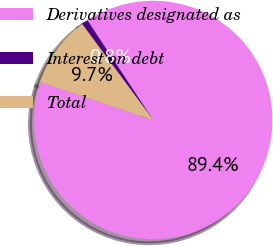Convert chart. <chart><loc_0><loc_0><loc_500><loc_500><pie_chart><fcel>Derivatives designated as<fcel>Interest on debt<fcel>Total<nl><fcel>89.45%<fcel>0.85%<fcel>9.71%<nl></chart> 